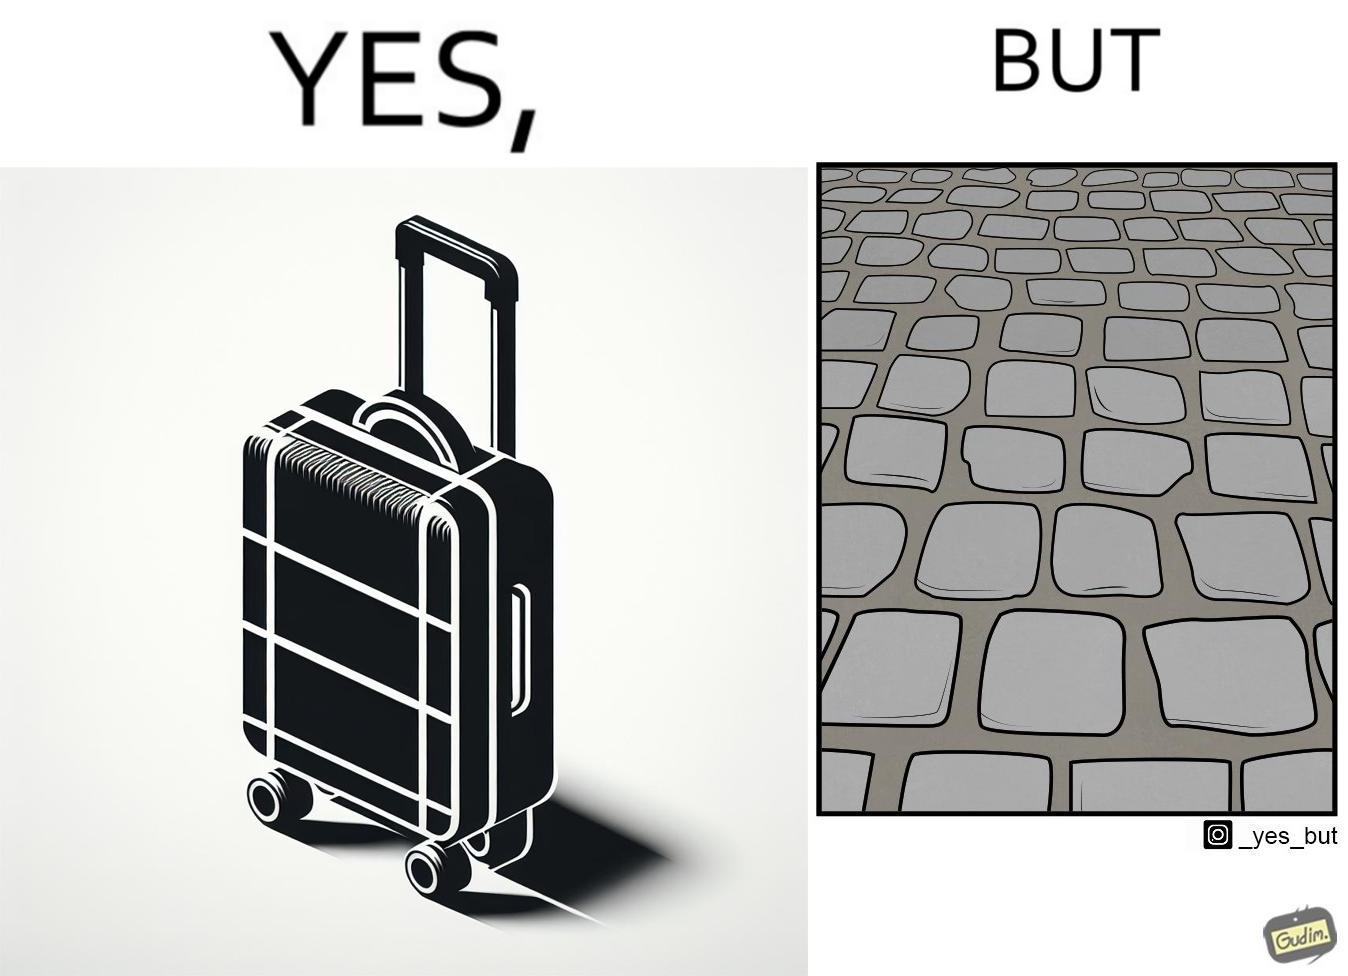Provide a description of this image. The image is funny because even though the trolley bag is made to make carrying luggage easy, as soon as it encounters a rough surface like cobblestone road, it makes carrying luggage more difficult. 